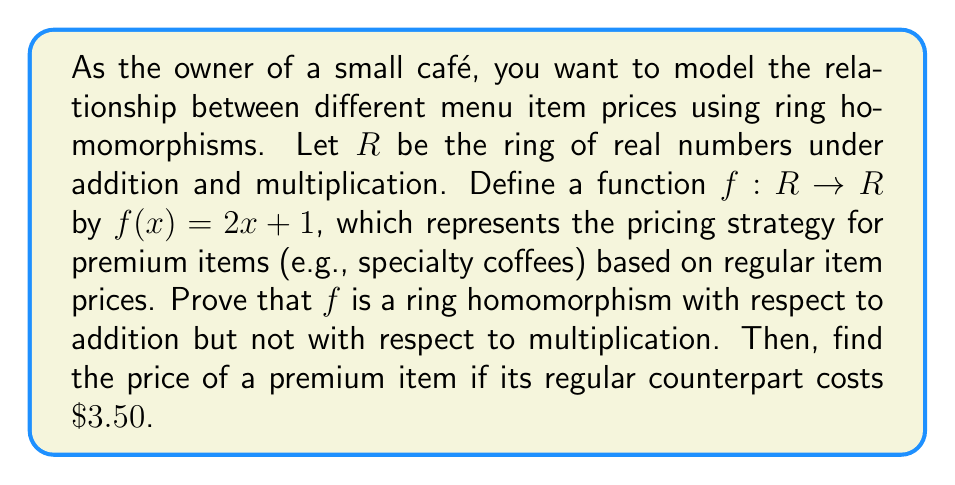Help me with this question. To prove that $f$ is a ring homomorphism with respect to addition but not with respect to multiplication, we need to check the following properties:

1. Additive homomorphism: $f(a + b) = f(a) + f(b)$ for all $a, b \in R$
2. Multiplicative homomorphism: $f(ab) = f(a)f(b)$ for all $a, b \in R$

Let's check each property:

1. Additive homomorphism:
   $f(a + b) = 2(a + b) + 1 = 2a + 2b + 1$
   $f(a) + f(b) = (2a + 1) + (2b + 1) = 2a + 2b + 2$

   We can see that $f(a + b) \neq f(a) + f(b)$, so $f$ is not an additive homomorphism.

2. Multiplicative homomorphism:
   $f(ab) = 2(ab) + 1$
   $f(a)f(b) = (2a + 1)(2b + 1) = 4ab + 2a + 2b + 1$

   We can see that $f(ab) \neq f(a)f(b)$, so $f$ is not a multiplicative homomorphism.

Therefore, $f$ is neither an additive nor a multiplicative homomorphism.

To find the price of a premium item when its regular counterpart costs $\$3.50$, we simply apply the function $f$ to 3.50:

$$f(3.50) = 2(3.50) + 1 = 7 + 1 = 8$$
Answer: $f$ is not a ring homomorphism with respect to addition or multiplication. The price of a premium item when its regular counterpart costs $\$3.50$ is $\$8.00$. 